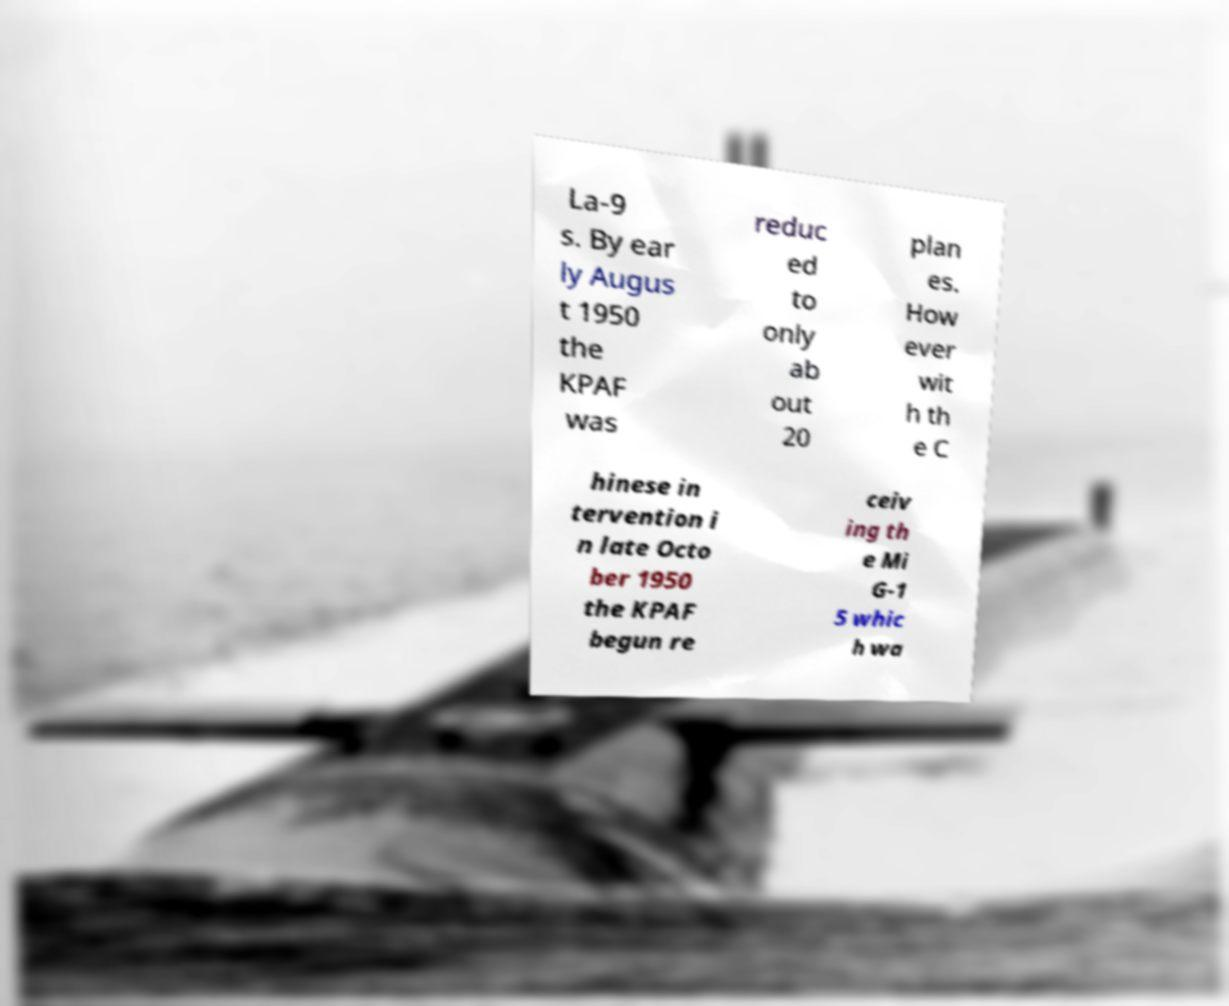Please read and relay the text visible in this image. What does it say? La-9 s. By ear ly Augus t 1950 the KPAF was reduc ed to only ab out 20 plan es. How ever wit h th e C hinese in tervention i n late Octo ber 1950 the KPAF begun re ceiv ing th e Mi G-1 5 whic h wa 